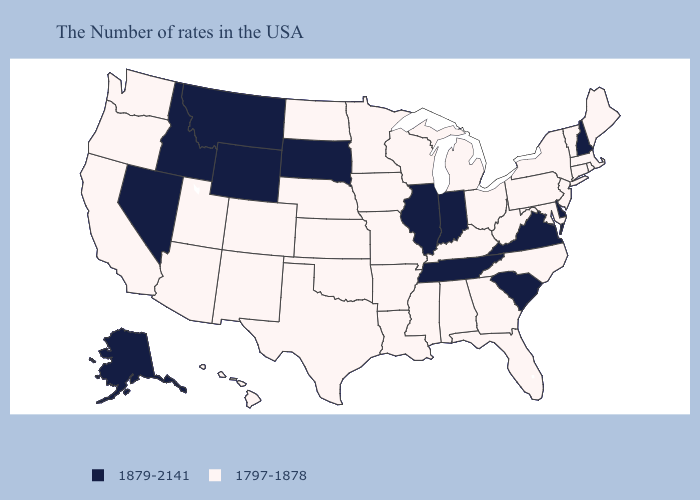Name the states that have a value in the range 1879-2141?
Be succinct. New Hampshire, Delaware, Virginia, South Carolina, Indiana, Tennessee, Illinois, South Dakota, Wyoming, Montana, Idaho, Nevada, Alaska. What is the value of Nebraska?
Answer briefly. 1797-1878. Does Nevada have the lowest value in the West?
Give a very brief answer. No. Name the states that have a value in the range 1879-2141?
Give a very brief answer. New Hampshire, Delaware, Virginia, South Carolina, Indiana, Tennessee, Illinois, South Dakota, Wyoming, Montana, Idaho, Nevada, Alaska. Which states have the lowest value in the Northeast?
Answer briefly. Maine, Massachusetts, Rhode Island, Vermont, Connecticut, New York, New Jersey, Pennsylvania. What is the value of North Carolina?
Quick response, please. 1797-1878. Name the states that have a value in the range 1797-1878?
Write a very short answer. Maine, Massachusetts, Rhode Island, Vermont, Connecticut, New York, New Jersey, Maryland, Pennsylvania, North Carolina, West Virginia, Ohio, Florida, Georgia, Michigan, Kentucky, Alabama, Wisconsin, Mississippi, Louisiana, Missouri, Arkansas, Minnesota, Iowa, Kansas, Nebraska, Oklahoma, Texas, North Dakota, Colorado, New Mexico, Utah, Arizona, California, Washington, Oregon, Hawaii. Among the states that border Minnesota , does South Dakota have the highest value?
Write a very short answer. Yes. What is the value of Delaware?
Short answer required. 1879-2141. Which states have the lowest value in the MidWest?
Give a very brief answer. Ohio, Michigan, Wisconsin, Missouri, Minnesota, Iowa, Kansas, Nebraska, North Dakota. Does the map have missing data?
Keep it brief. No. Does Florida have a higher value than North Dakota?
Concise answer only. No. Does Texas have a lower value than Ohio?
Give a very brief answer. No. What is the lowest value in the MidWest?
Be succinct. 1797-1878. Does South Dakota have the lowest value in the USA?
Quick response, please. No. 